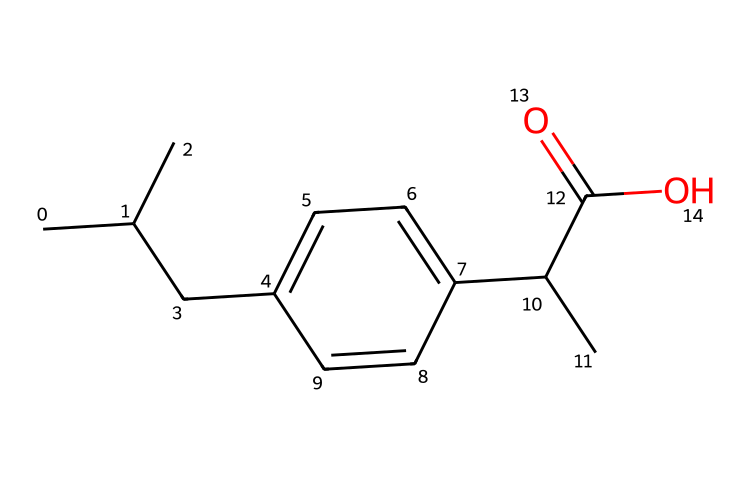What is the name of this chemical? The structure corresponds to ibuprofen, which is a well-known nonsteroidal anti-inflammatory drug (NSAID) used for pain relief and reducing inflammation.
Answer: ibuprofen How many carbon atoms are present in this molecule? By analyzing the SMILES representation, we can count the number of carbon atoms represented by 'C' and its connectivity. There are 13 carbon atoms in total in the structure of ibuprofen.
Answer: 13 What functional group is present in this chemical? The presence of the '-C(=O)O' part of the structure indicates that there is a carboxylic acid functional group in ibuprofen. This group is responsible for some of its chemical reactivity and properties.
Answer: carboxylic acid How many double bonds are there in this chemical? The examination of the SMILES reveals the 'C=C' connection, indicating that there are two carbon-carbon double bonds in the molecule. Therefore, the structure contains two double bonds.
Answer: 2 What is the primary mechanism of action of ibuprofen at the molecular level? Ibuprofen primarily works by inhibiting the enzyme cyclooxygenase (COX), which is responsible for the production of prostaglandins that mediate pain and inflammation. This inhibition occurs at a molecular level where ibuprofen binds to COX, effectively reducing its activity.
Answer: COX inhibition What aspect of ibuprofen's structure allows it to be classified as a nonsteroidal anti-inflammatory drug? The presence of the aromatic ring and the carboxylic acid functional group in ibuprofen's structure allows it to exert anti-inflammatory effects. This structural composition differentiates it from steroid-based anti-inflammatories.
Answer: aromatic ring and carboxylic acid 